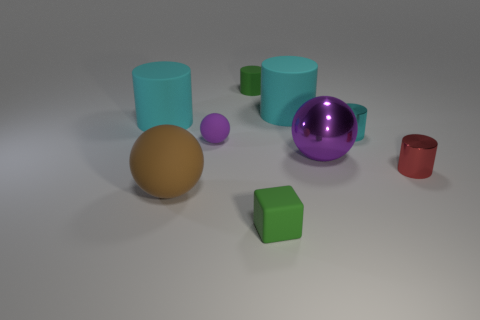What might be the purpose of arranging these objects together? The arrangement of the objects seems to be for a composition exercise, likely to study forms, colors, and shadows in a controlled lighting environment, which is often done in a study of computer graphics or photography. 